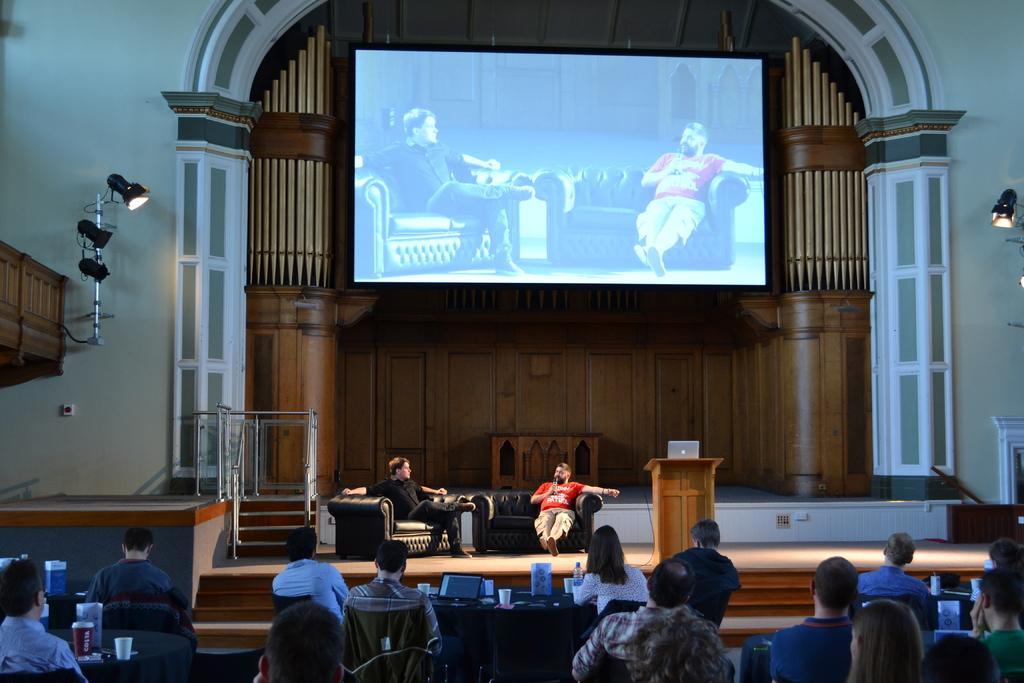How would you summarize this image in a sentence or two? In this picture we can see group of people, they are all sitting, in front of them we can see few cups, bottles and other things on the tables, in the background we can see a laptop on the podium, also we can see a projector screen, few lights and metal rods. 